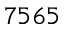<formula> <loc_0><loc_0><loc_500><loc_500>7 5 6 5</formula> 